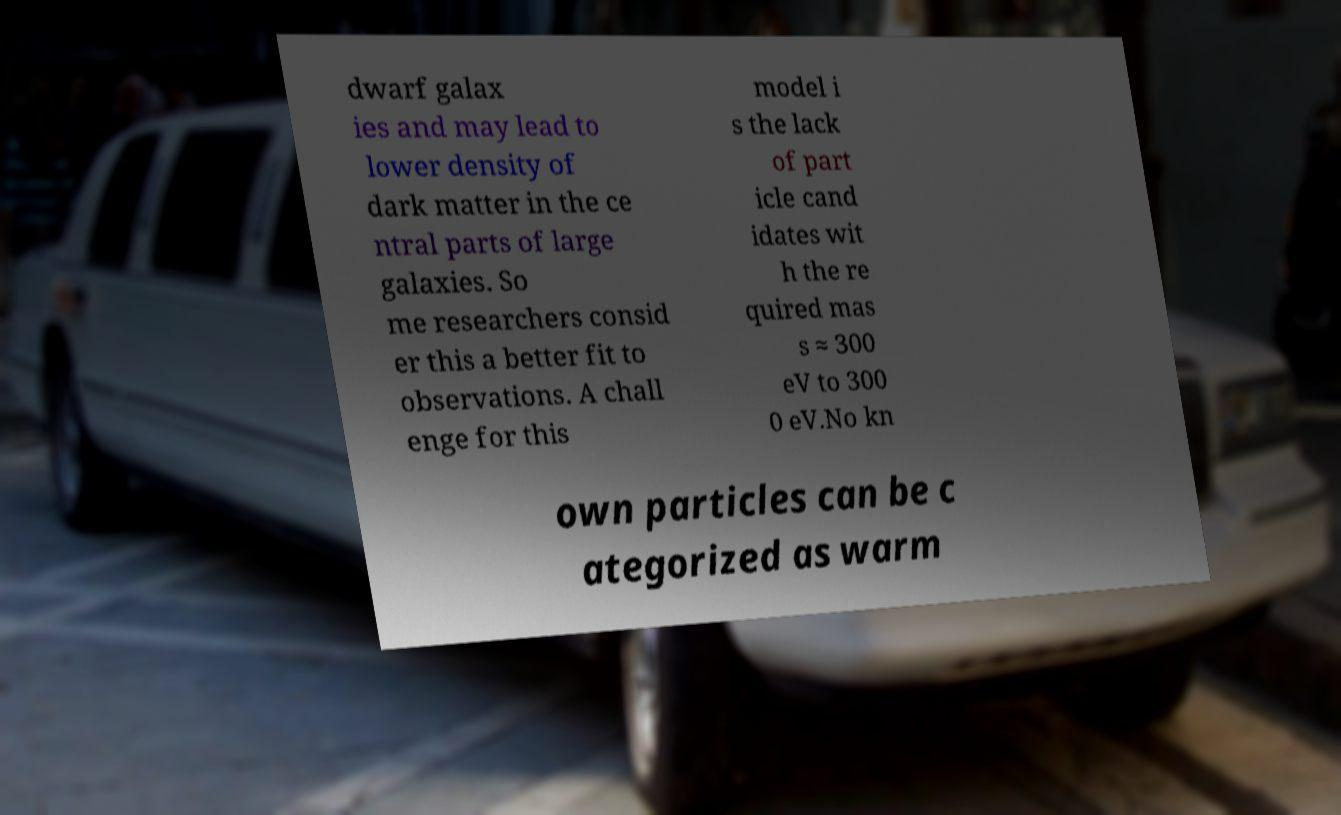Please read and relay the text visible in this image. What does it say? dwarf galax ies and may lead to lower density of dark matter in the ce ntral parts of large galaxies. So me researchers consid er this a better fit to observations. A chall enge for this model i s the lack of part icle cand idates wit h the re quired mas s ≈ 300 eV to 300 0 eV.No kn own particles can be c ategorized as warm 